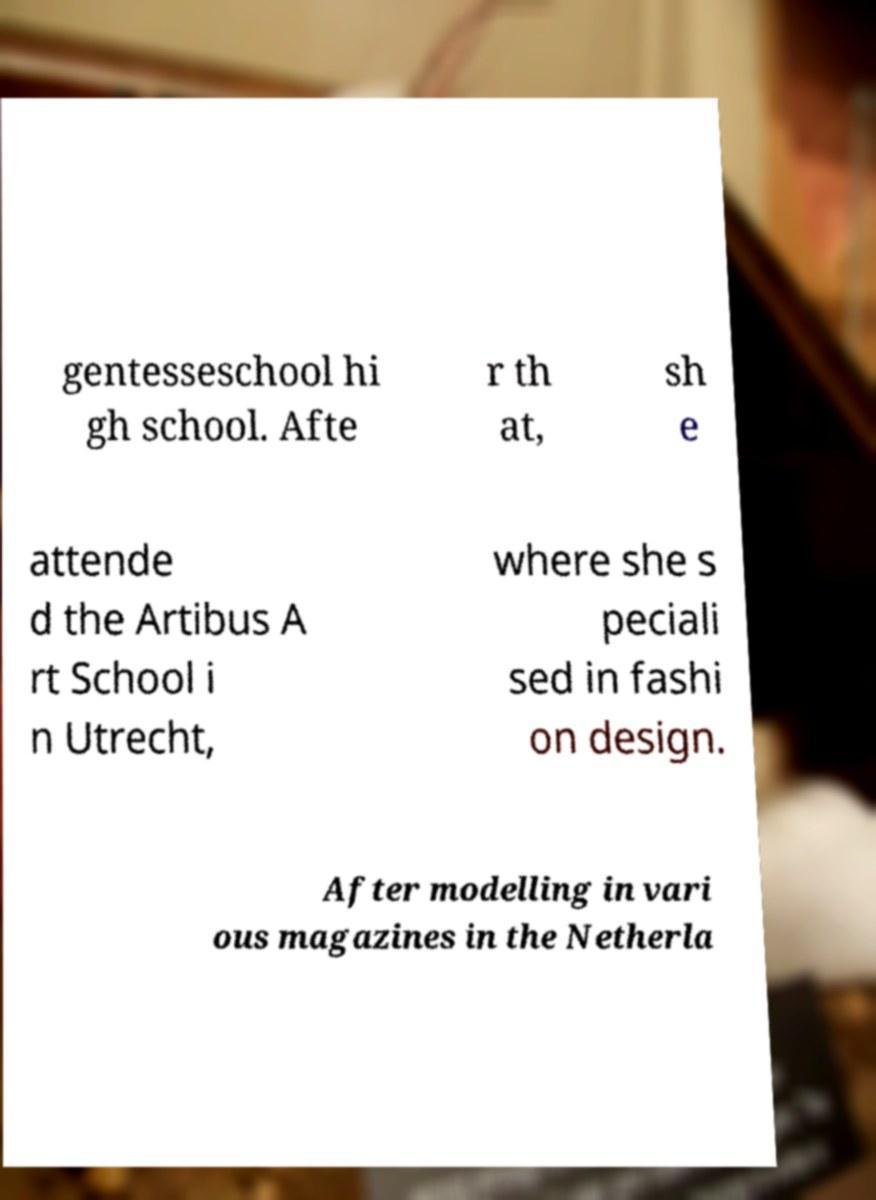Please identify and transcribe the text found in this image. gentesseschool hi gh school. Afte r th at, sh e attende d the Artibus A rt School i n Utrecht, where she s peciali sed in fashi on design. After modelling in vari ous magazines in the Netherla 